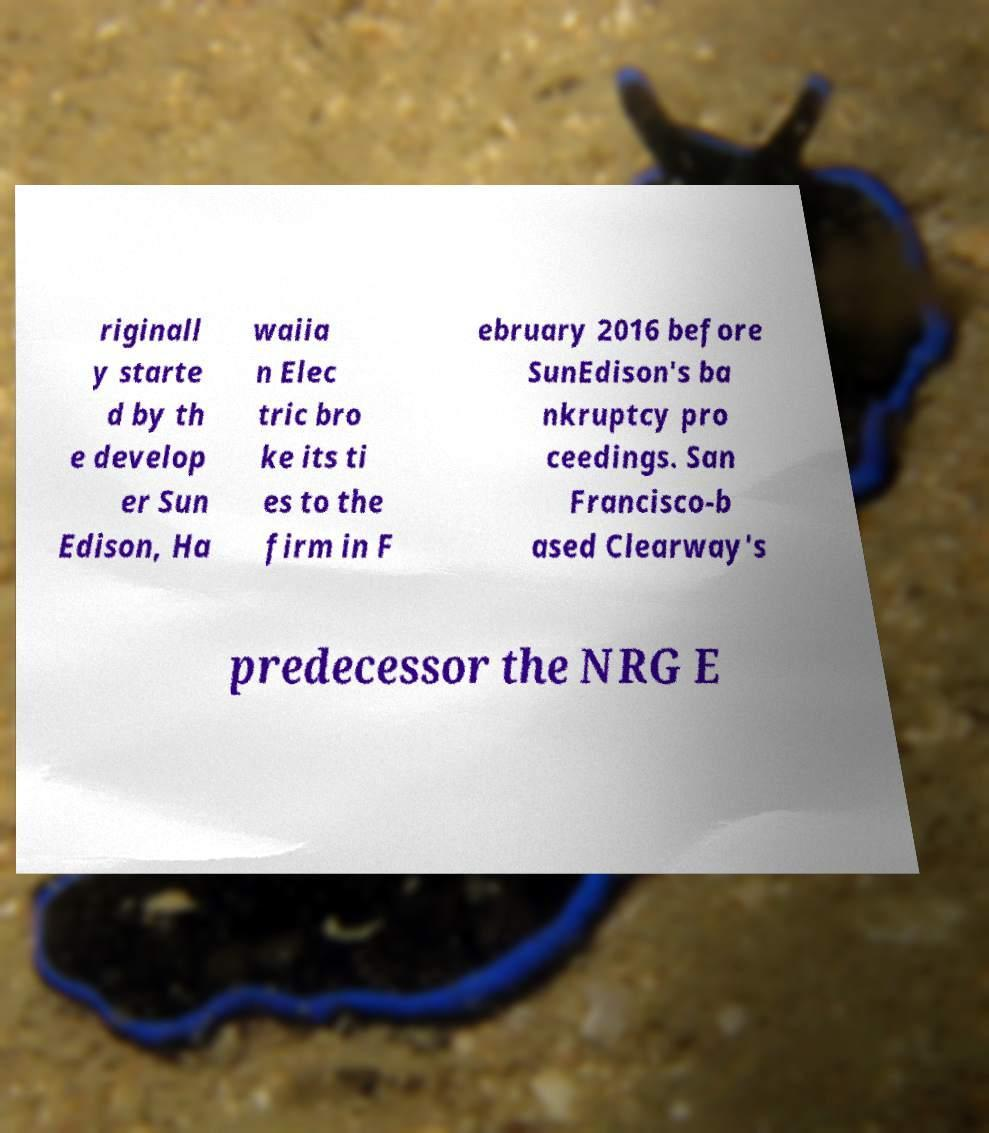There's text embedded in this image that I need extracted. Can you transcribe it verbatim? riginall y starte d by th e develop er Sun Edison, Ha waiia n Elec tric bro ke its ti es to the firm in F ebruary 2016 before SunEdison's ba nkruptcy pro ceedings. San Francisco-b ased Clearway's predecessor the NRG E 